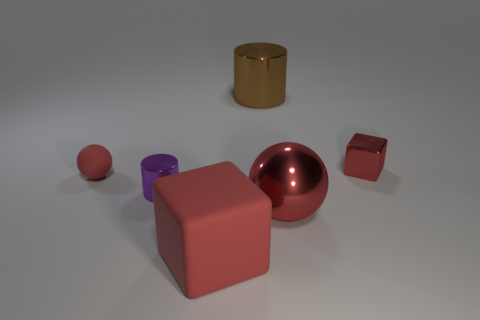The big object that is the same shape as the tiny rubber object is what color?
Give a very brief answer. Red. What is the shape of the tiny metal thing behind the red rubber thing left of the big red thing left of the brown metallic thing?
Ensure brevity in your answer.  Cube. Is the brown metal object the same shape as the purple metal object?
Your response must be concise. Yes. The red matte thing that is behind the rubber object that is in front of the metallic ball is what shape?
Your response must be concise. Sphere. Is there a large gray metallic cube?
Offer a very short reply. No. What number of small red blocks are on the left side of the red ball to the left of the big metal object that is in front of the tiny metal cube?
Your response must be concise. 0. There is a tiny purple thing; does it have the same shape as the matte thing that is left of the large red rubber thing?
Offer a very short reply. No. Are there more small blue rubber cylinders than big metallic cylinders?
Offer a terse response. No. There is a big metallic object in front of the large cylinder; does it have the same shape as the small red matte object?
Your answer should be compact. Yes. Is the number of metal objects that are in front of the purple shiny thing greater than the number of tiny brown metal balls?
Your answer should be compact. Yes. 